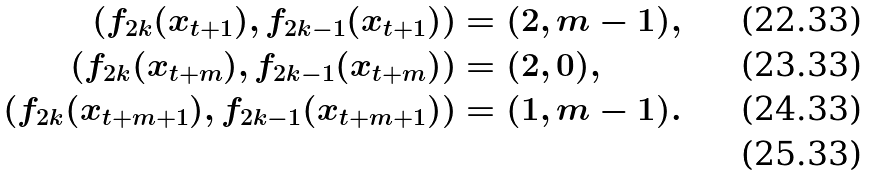<formula> <loc_0><loc_0><loc_500><loc_500>\left ( f _ { 2 k } ( x _ { t + 1 } ) , f _ { 2 k - 1 } ( x _ { t + 1 } ) \right ) & = ( 2 , m - 1 ) , \\ \left ( f _ { 2 k } ( x _ { t + m } ) , f _ { 2 k - 1 } ( x _ { t + m } ) \right ) & = ( 2 , 0 ) , \\ \left ( f _ { 2 k } ( x _ { t + m + 1 } ) , f _ { 2 k - 1 } ( x _ { t + m + 1 } ) \right ) & = ( 1 , m - 1 ) . \\</formula> 